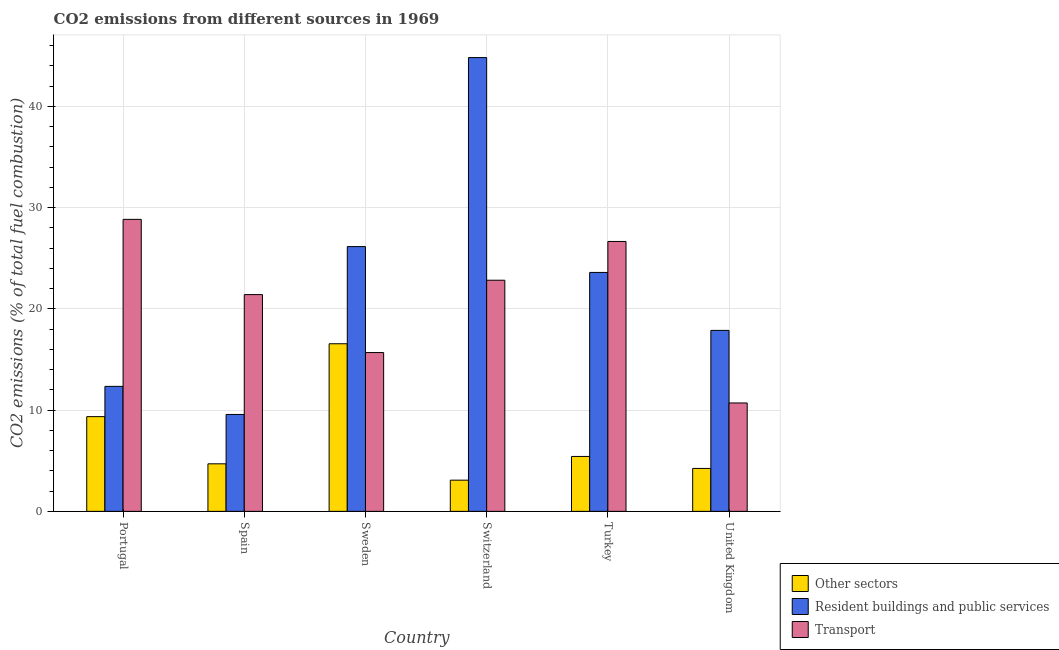How many different coloured bars are there?
Offer a very short reply. 3. How many groups of bars are there?
Provide a succinct answer. 6. How many bars are there on the 4th tick from the left?
Offer a terse response. 3. How many bars are there on the 4th tick from the right?
Your response must be concise. 3. What is the percentage of co2 emissions from other sectors in Sweden?
Your answer should be very brief. 16.55. Across all countries, what is the maximum percentage of co2 emissions from transport?
Your answer should be compact. 28.83. Across all countries, what is the minimum percentage of co2 emissions from resident buildings and public services?
Ensure brevity in your answer.  9.57. In which country was the percentage of co2 emissions from resident buildings and public services maximum?
Provide a succinct answer. Switzerland. What is the total percentage of co2 emissions from resident buildings and public services in the graph?
Make the answer very short. 134.33. What is the difference between the percentage of co2 emissions from transport in Sweden and that in Switzerland?
Offer a terse response. -7.14. What is the difference between the percentage of co2 emissions from transport in Sweden and the percentage of co2 emissions from resident buildings and public services in Spain?
Give a very brief answer. 6.11. What is the average percentage of co2 emissions from other sectors per country?
Give a very brief answer. 7.22. What is the difference between the percentage of co2 emissions from other sectors and percentage of co2 emissions from transport in Spain?
Provide a succinct answer. -16.71. What is the ratio of the percentage of co2 emissions from resident buildings and public services in Sweden to that in Turkey?
Your answer should be compact. 1.11. Is the percentage of co2 emissions from other sectors in Spain less than that in United Kingdom?
Offer a terse response. No. What is the difference between the highest and the second highest percentage of co2 emissions from resident buildings and public services?
Make the answer very short. 18.66. What is the difference between the highest and the lowest percentage of co2 emissions from transport?
Your answer should be compact. 18.13. In how many countries, is the percentage of co2 emissions from resident buildings and public services greater than the average percentage of co2 emissions from resident buildings and public services taken over all countries?
Your answer should be compact. 3. What does the 3rd bar from the left in Portugal represents?
Your answer should be very brief. Transport. What does the 2nd bar from the right in Switzerland represents?
Offer a terse response. Resident buildings and public services. How many countries are there in the graph?
Offer a terse response. 6. What is the difference between two consecutive major ticks on the Y-axis?
Your response must be concise. 10. Does the graph contain any zero values?
Your response must be concise. No. Does the graph contain grids?
Make the answer very short. Yes. Where does the legend appear in the graph?
Ensure brevity in your answer.  Bottom right. How many legend labels are there?
Your response must be concise. 3. What is the title of the graph?
Give a very brief answer. CO2 emissions from different sources in 1969. Does "Ages 50+" appear as one of the legend labels in the graph?
Provide a short and direct response. No. What is the label or title of the X-axis?
Your answer should be very brief. Country. What is the label or title of the Y-axis?
Your answer should be compact. CO2 emissions (% of total fuel combustion). What is the CO2 emissions (% of total fuel combustion) in Other sectors in Portugal?
Your answer should be very brief. 9.35. What is the CO2 emissions (% of total fuel combustion) in Resident buildings and public services in Portugal?
Ensure brevity in your answer.  12.34. What is the CO2 emissions (% of total fuel combustion) of Transport in Portugal?
Offer a very short reply. 28.83. What is the CO2 emissions (% of total fuel combustion) in Other sectors in Spain?
Ensure brevity in your answer.  4.69. What is the CO2 emissions (% of total fuel combustion) of Resident buildings and public services in Spain?
Your response must be concise. 9.57. What is the CO2 emissions (% of total fuel combustion) in Transport in Spain?
Make the answer very short. 21.4. What is the CO2 emissions (% of total fuel combustion) in Other sectors in Sweden?
Keep it short and to the point. 16.55. What is the CO2 emissions (% of total fuel combustion) of Resident buildings and public services in Sweden?
Your answer should be compact. 26.15. What is the CO2 emissions (% of total fuel combustion) of Transport in Sweden?
Ensure brevity in your answer.  15.68. What is the CO2 emissions (% of total fuel combustion) of Other sectors in Switzerland?
Offer a very short reply. 3.08. What is the CO2 emissions (% of total fuel combustion) in Resident buildings and public services in Switzerland?
Your response must be concise. 44.81. What is the CO2 emissions (% of total fuel combustion) of Transport in Switzerland?
Offer a terse response. 22.82. What is the CO2 emissions (% of total fuel combustion) of Other sectors in Turkey?
Provide a short and direct response. 5.42. What is the CO2 emissions (% of total fuel combustion) in Resident buildings and public services in Turkey?
Provide a short and direct response. 23.59. What is the CO2 emissions (% of total fuel combustion) in Transport in Turkey?
Your answer should be very brief. 26.65. What is the CO2 emissions (% of total fuel combustion) in Other sectors in United Kingdom?
Ensure brevity in your answer.  4.24. What is the CO2 emissions (% of total fuel combustion) in Resident buildings and public services in United Kingdom?
Keep it short and to the point. 17.87. What is the CO2 emissions (% of total fuel combustion) in Transport in United Kingdom?
Offer a terse response. 10.7. Across all countries, what is the maximum CO2 emissions (% of total fuel combustion) in Other sectors?
Ensure brevity in your answer.  16.55. Across all countries, what is the maximum CO2 emissions (% of total fuel combustion) in Resident buildings and public services?
Your answer should be compact. 44.81. Across all countries, what is the maximum CO2 emissions (% of total fuel combustion) in Transport?
Your response must be concise. 28.83. Across all countries, what is the minimum CO2 emissions (% of total fuel combustion) of Other sectors?
Ensure brevity in your answer.  3.08. Across all countries, what is the minimum CO2 emissions (% of total fuel combustion) in Resident buildings and public services?
Keep it short and to the point. 9.57. Across all countries, what is the minimum CO2 emissions (% of total fuel combustion) in Transport?
Ensure brevity in your answer.  10.7. What is the total CO2 emissions (% of total fuel combustion) in Other sectors in the graph?
Your response must be concise. 43.34. What is the total CO2 emissions (% of total fuel combustion) in Resident buildings and public services in the graph?
Your answer should be very brief. 134.33. What is the total CO2 emissions (% of total fuel combustion) in Transport in the graph?
Offer a terse response. 126.1. What is the difference between the CO2 emissions (% of total fuel combustion) of Other sectors in Portugal and that in Spain?
Offer a very short reply. 4.66. What is the difference between the CO2 emissions (% of total fuel combustion) in Resident buildings and public services in Portugal and that in Spain?
Make the answer very short. 2.78. What is the difference between the CO2 emissions (% of total fuel combustion) of Transport in Portugal and that in Spain?
Provide a succinct answer. 7.43. What is the difference between the CO2 emissions (% of total fuel combustion) in Other sectors in Portugal and that in Sweden?
Give a very brief answer. -7.2. What is the difference between the CO2 emissions (% of total fuel combustion) of Resident buildings and public services in Portugal and that in Sweden?
Your answer should be very brief. -13.8. What is the difference between the CO2 emissions (% of total fuel combustion) of Transport in Portugal and that in Sweden?
Keep it short and to the point. 13.15. What is the difference between the CO2 emissions (% of total fuel combustion) in Other sectors in Portugal and that in Switzerland?
Your answer should be very brief. 6.27. What is the difference between the CO2 emissions (% of total fuel combustion) in Resident buildings and public services in Portugal and that in Switzerland?
Your answer should be compact. -32.47. What is the difference between the CO2 emissions (% of total fuel combustion) in Transport in Portugal and that in Switzerland?
Provide a short and direct response. 6.01. What is the difference between the CO2 emissions (% of total fuel combustion) in Other sectors in Portugal and that in Turkey?
Your response must be concise. 3.93. What is the difference between the CO2 emissions (% of total fuel combustion) of Resident buildings and public services in Portugal and that in Turkey?
Your response must be concise. -11.25. What is the difference between the CO2 emissions (% of total fuel combustion) in Transport in Portugal and that in Turkey?
Your answer should be very brief. 2.18. What is the difference between the CO2 emissions (% of total fuel combustion) in Other sectors in Portugal and that in United Kingdom?
Your answer should be compact. 5.11. What is the difference between the CO2 emissions (% of total fuel combustion) of Resident buildings and public services in Portugal and that in United Kingdom?
Give a very brief answer. -5.53. What is the difference between the CO2 emissions (% of total fuel combustion) in Transport in Portugal and that in United Kingdom?
Ensure brevity in your answer.  18.13. What is the difference between the CO2 emissions (% of total fuel combustion) in Other sectors in Spain and that in Sweden?
Provide a short and direct response. -11.85. What is the difference between the CO2 emissions (% of total fuel combustion) of Resident buildings and public services in Spain and that in Sweden?
Keep it short and to the point. -16.58. What is the difference between the CO2 emissions (% of total fuel combustion) of Transport in Spain and that in Sweden?
Make the answer very short. 5.72. What is the difference between the CO2 emissions (% of total fuel combustion) in Other sectors in Spain and that in Switzerland?
Offer a terse response. 1.61. What is the difference between the CO2 emissions (% of total fuel combustion) in Resident buildings and public services in Spain and that in Switzerland?
Ensure brevity in your answer.  -35.24. What is the difference between the CO2 emissions (% of total fuel combustion) in Transport in Spain and that in Switzerland?
Make the answer very short. -1.42. What is the difference between the CO2 emissions (% of total fuel combustion) in Other sectors in Spain and that in Turkey?
Give a very brief answer. -0.73. What is the difference between the CO2 emissions (% of total fuel combustion) in Resident buildings and public services in Spain and that in Turkey?
Keep it short and to the point. -14.03. What is the difference between the CO2 emissions (% of total fuel combustion) of Transport in Spain and that in Turkey?
Your response must be concise. -5.25. What is the difference between the CO2 emissions (% of total fuel combustion) of Other sectors in Spain and that in United Kingdom?
Make the answer very short. 0.46. What is the difference between the CO2 emissions (% of total fuel combustion) in Resident buildings and public services in Spain and that in United Kingdom?
Provide a succinct answer. -8.3. What is the difference between the CO2 emissions (% of total fuel combustion) of Transport in Spain and that in United Kingdom?
Provide a short and direct response. 10.7. What is the difference between the CO2 emissions (% of total fuel combustion) of Other sectors in Sweden and that in Switzerland?
Make the answer very short. 13.47. What is the difference between the CO2 emissions (% of total fuel combustion) of Resident buildings and public services in Sweden and that in Switzerland?
Provide a short and direct response. -18.66. What is the difference between the CO2 emissions (% of total fuel combustion) in Transport in Sweden and that in Switzerland?
Provide a succinct answer. -7.14. What is the difference between the CO2 emissions (% of total fuel combustion) of Other sectors in Sweden and that in Turkey?
Keep it short and to the point. 11.13. What is the difference between the CO2 emissions (% of total fuel combustion) in Resident buildings and public services in Sweden and that in Turkey?
Keep it short and to the point. 2.55. What is the difference between the CO2 emissions (% of total fuel combustion) of Transport in Sweden and that in Turkey?
Ensure brevity in your answer.  -10.97. What is the difference between the CO2 emissions (% of total fuel combustion) in Other sectors in Sweden and that in United Kingdom?
Provide a short and direct response. 12.31. What is the difference between the CO2 emissions (% of total fuel combustion) of Resident buildings and public services in Sweden and that in United Kingdom?
Provide a succinct answer. 8.28. What is the difference between the CO2 emissions (% of total fuel combustion) of Transport in Sweden and that in United Kingdom?
Make the answer very short. 4.98. What is the difference between the CO2 emissions (% of total fuel combustion) in Other sectors in Switzerland and that in Turkey?
Your answer should be compact. -2.34. What is the difference between the CO2 emissions (% of total fuel combustion) of Resident buildings and public services in Switzerland and that in Turkey?
Offer a very short reply. 21.22. What is the difference between the CO2 emissions (% of total fuel combustion) of Transport in Switzerland and that in Turkey?
Offer a very short reply. -3.83. What is the difference between the CO2 emissions (% of total fuel combustion) of Other sectors in Switzerland and that in United Kingdom?
Ensure brevity in your answer.  -1.16. What is the difference between the CO2 emissions (% of total fuel combustion) of Resident buildings and public services in Switzerland and that in United Kingdom?
Provide a succinct answer. 26.94. What is the difference between the CO2 emissions (% of total fuel combustion) of Transport in Switzerland and that in United Kingdom?
Your response must be concise. 12.12. What is the difference between the CO2 emissions (% of total fuel combustion) of Other sectors in Turkey and that in United Kingdom?
Ensure brevity in your answer.  1.18. What is the difference between the CO2 emissions (% of total fuel combustion) in Resident buildings and public services in Turkey and that in United Kingdom?
Provide a succinct answer. 5.72. What is the difference between the CO2 emissions (% of total fuel combustion) in Transport in Turkey and that in United Kingdom?
Keep it short and to the point. 15.95. What is the difference between the CO2 emissions (% of total fuel combustion) in Other sectors in Portugal and the CO2 emissions (% of total fuel combustion) in Resident buildings and public services in Spain?
Offer a very short reply. -0.21. What is the difference between the CO2 emissions (% of total fuel combustion) in Other sectors in Portugal and the CO2 emissions (% of total fuel combustion) in Transport in Spain?
Your response must be concise. -12.05. What is the difference between the CO2 emissions (% of total fuel combustion) of Resident buildings and public services in Portugal and the CO2 emissions (% of total fuel combustion) of Transport in Spain?
Provide a succinct answer. -9.06. What is the difference between the CO2 emissions (% of total fuel combustion) of Other sectors in Portugal and the CO2 emissions (% of total fuel combustion) of Resident buildings and public services in Sweden?
Ensure brevity in your answer.  -16.79. What is the difference between the CO2 emissions (% of total fuel combustion) of Other sectors in Portugal and the CO2 emissions (% of total fuel combustion) of Transport in Sweden?
Give a very brief answer. -6.33. What is the difference between the CO2 emissions (% of total fuel combustion) of Resident buildings and public services in Portugal and the CO2 emissions (% of total fuel combustion) of Transport in Sweden?
Make the answer very short. -3.34. What is the difference between the CO2 emissions (% of total fuel combustion) in Other sectors in Portugal and the CO2 emissions (% of total fuel combustion) in Resident buildings and public services in Switzerland?
Provide a succinct answer. -35.46. What is the difference between the CO2 emissions (% of total fuel combustion) in Other sectors in Portugal and the CO2 emissions (% of total fuel combustion) in Transport in Switzerland?
Your answer should be very brief. -13.47. What is the difference between the CO2 emissions (% of total fuel combustion) in Resident buildings and public services in Portugal and the CO2 emissions (% of total fuel combustion) in Transport in Switzerland?
Your response must be concise. -10.48. What is the difference between the CO2 emissions (% of total fuel combustion) in Other sectors in Portugal and the CO2 emissions (% of total fuel combustion) in Resident buildings and public services in Turkey?
Keep it short and to the point. -14.24. What is the difference between the CO2 emissions (% of total fuel combustion) in Other sectors in Portugal and the CO2 emissions (% of total fuel combustion) in Transport in Turkey?
Ensure brevity in your answer.  -17.3. What is the difference between the CO2 emissions (% of total fuel combustion) in Resident buildings and public services in Portugal and the CO2 emissions (% of total fuel combustion) in Transport in Turkey?
Your answer should be very brief. -14.31. What is the difference between the CO2 emissions (% of total fuel combustion) of Other sectors in Portugal and the CO2 emissions (% of total fuel combustion) of Resident buildings and public services in United Kingdom?
Provide a succinct answer. -8.52. What is the difference between the CO2 emissions (% of total fuel combustion) in Other sectors in Portugal and the CO2 emissions (% of total fuel combustion) in Transport in United Kingdom?
Your answer should be compact. -1.35. What is the difference between the CO2 emissions (% of total fuel combustion) of Resident buildings and public services in Portugal and the CO2 emissions (% of total fuel combustion) of Transport in United Kingdom?
Provide a short and direct response. 1.64. What is the difference between the CO2 emissions (% of total fuel combustion) of Other sectors in Spain and the CO2 emissions (% of total fuel combustion) of Resident buildings and public services in Sweden?
Keep it short and to the point. -21.45. What is the difference between the CO2 emissions (% of total fuel combustion) in Other sectors in Spain and the CO2 emissions (% of total fuel combustion) in Transport in Sweden?
Your answer should be very brief. -10.99. What is the difference between the CO2 emissions (% of total fuel combustion) of Resident buildings and public services in Spain and the CO2 emissions (% of total fuel combustion) of Transport in Sweden?
Offer a terse response. -6.11. What is the difference between the CO2 emissions (% of total fuel combustion) in Other sectors in Spain and the CO2 emissions (% of total fuel combustion) in Resident buildings and public services in Switzerland?
Offer a very short reply. -40.12. What is the difference between the CO2 emissions (% of total fuel combustion) in Other sectors in Spain and the CO2 emissions (% of total fuel combustion) in Transport in Switzerland?
Your answer should be very brief. -18.13. What is the difference between the CO2 emissions (% of total fuel combustion) of Resident buildings and public services in Spain and the CO2 emissions (% of total fuel combustion) of Transport in Switzerland?
Make the answer very short. -13.26. What is the difference between the CO2 emissions (% of total fuel combustion) of Other sectors in Spain and the CO2 emissions (% of total fuel combustion) of Resident buildings and public services in Turkey?
Ensure brevity in your answer.  -18.9. What is the difference between the CO2 emissions (% of total fuel combustion) of Other sectors in Spain and the CO2 emissions (% of total fuel combustion) of Transport in Turkey?
Your answer should be very brief. -21.96. What is the difference between the CO2 emissions (% of total fuel combustion) in Resident buildings and public services in Spain and the CO2 emissions (% of total fuel combustion) in Transport in Turkey?
Ensure brevity in your answer.  -17.08. What is the difference between the CO2 emissions (% of total fuel combustion) of Other sectors in Spain and the CO2 emissions (% of total fuel combustion) of Resident buildings and public services in United Kingdom?
Your answer should be compact. -13.17. What is the difference between the CO2 emissions (% of total fuel combustion) of Other sectors in Spain and the CO2 emissions (% of total fuel combustion) of Transport in United Kingdom?
Provide a succinct answer. -6.01. What is the difference between the CO2 emissions (% of total fuel combustion) in Resident buildings and public services in Spain and the CO2 emissions (% of total fuel combustion) in Transport in United Kingdom?
Your response must be concise. -1.14. What is the difference between the CO2 emissions (% of total fuel combustion) of Other sectors in Sweden and the CO2 emissions (% of total fuel combustion) of Resident buildings and public services in Switzerland?
Provide a short and direct response. -28.26. What is the difference between the CO2 emissions (% of total fuel combustion) of Other sectors in Sweden and the CO2 emissions (% of total fuel combustion) of Transport in Switzerland?
Your answer should be compact. -6.27. What is the difference between the CO2 emissions (% of total fuel combustion) in Resident buildings and public services in Sweden and the CO2 emissions (% of total fuel combustion) in Transport in Switzerland?
Offer a terse response. 3.32. What is the difference between the CO2 emissions (% of total fuel combustion) in Other sectors in Sweden and the CO2 emissions (% of total fuel combustion) in Resident buildings and public services in Turkey?
Keep it short and to the point. -7.04. What is the difference between the CO2 emissions (% of total fuel combustion) in Other sectors in Sweden and the CO2 emissions (% of total fuel combustion) in Transport in Turkey?
Your answer should be very brief. -10.1. What is the difference between the CO2 emissions (% of total fuel combustion) in Resident buildings and public services in Sweden and the CO2 emissions (% of total fuel combustion) in Transport in Turkey?
Offer a very short reply. -0.51. What is the difference between the CO2 emissions (% of total fuel combustion) of Other sectors in Sweden and the CO2 emissions (% of total fuel combustion) of Resident buildings and public services in United Kingdom?
Keep it short and to the point. -1.32. What is the difference between the CO2 emissions (% of total fuel combustion) of Other sectors in Sweden and the CO2 emissions (% of total fuel combustion) of Transport in United Kingdom?
Make the answer very short. 5.85. What is the difference between the CO2 emissions (% of total fuel combustion) in Resident buildings and public services in Sweden and the CO2 emissions (% of total fuel combustion) in Transport in United Kingdom?
Offer a very short reply. 15.44. What is the difference between the CO2 emissions (% of total fuel combustion) of Other sectors in Switzerland and the CO2 emissions (% of total fuel combustion) of Resident buildings and public services in Turkey?
Give a very brief answer. -20.51. What is the difference between the CO2 emissions (% of total fuel combustion) of Other sectors in Switzerland and the CO2 emissions (% of total fuel combustion) of Transport in Turkey?
Keep it short and to the point. -23.57. What is the difference between the CO2 emissions (% of total fuel combustion) in Resident buildings and public services in Switzerland and the CO2 emissions (% of total fuel combustion) in Transport in Turkey?
Keep it short and to the point. 18.16. What is the difference between the CO2 emissions (% of total fuel combustion) in Other sectors in Switzerland and the CO2 emissions (% of total fuel combustion) in Resident buildings and public services in United Kingdom?
Give a very brief answer. -14.79. What is the difference between the CO2 emissions (% of total fuel combustion) in Other sectors in Switzerland and the CO2 emissions (% of total fuel combustion) in Transport in United Kingdom?
Provide a short and direct response. -7.62. What is the difference between the CO2 emissions (% of total fuel combustion) in Resident buildings and public services in Switzerland and the CO2 emissions (% of total fuel combustion) in Transport in United Kingdom?
Offer a very short reply. 34.11. What is the difference between the CO2 emissions (% of total fuel combustion) of Other sectors in Turkey and the CO2 emissions (% of total fuel combustion) of Resident buildings and public services in United Kingdom?
Offer a very short reply. -12.45. What is the difference between the CO2 emissions (% of total fuel combustion) of Other sectors in Turkey and the CO2 emissions (% of total fuel combustion) of Transport in United Kingdom?
Give a very brief answer. -5.28. What is the difference between the CO2 emissions (% of total fuel combustion) of Resident buildings and public services in Turkey and the CO2 emissions (% of total fuel combustion) of Transport in United Kingdom?
Keep it short and to the point. 12.89. What is the average CO2 emissions (% of total fuel combustion) in Other sectors per country?
Your answer should be compact. 7.22. What is the average CO2 emissions (% of total fuel combustion) in Resident buildings and public services per country?
Provide a short and direct response. 22.39. What is the average CO2 emissions (% of total fuel combustion) in Transport per country?
Offer a very short reply. 21.02. What is the difference between the CO2 emissions (% of total fuel combustion) of Other sectors and CO2 emissions (% of total fuel combustion) of Resident buildings and public services in Portugal?
Your answer should be very brief. -2.99. What is the difference between the CO2 emissions (% of total fuel combustion) of Other sectors and CO2 emissions (% of total fuel combustion) of Transport in Portugal?
Provide a short and direct response. -19.48. What is the difference between the CO2 emissions (% of total fuel combustion) in Resident buildings and public services and CO2 emissions (% of total fuel combustion) in Transport in Portugal?
Offer a very short reply. -16.49. What is the difference between the CO2 emissions (% of total fuel combustion) of Other sectors and CO2 emissions (% of total fuel combustion) of Resident buildings and public services in Spain?
Provide a short and direct response. -4.87. What is the difference between the CO2 emissions (% of total fuel combustion) in Other sectors and CO2 emissions (% of total fuel combustion) in Transport in Spain?
Make the answer very short. -16.71. What is the difference between the CO2 emissions (% of total fuel combustion) in Resident buildings and public services and CO2 emissions (% of total fuel combustion) in Transport in Spain?
Your answer should be compact. -11.84. What is the difference between the CO2 emissions (% of total fuel combustion) in Other sectors and CO2 emissions (% of total fuel combustion) in Resident buildings and public services in Sweden?
Keep it short and to the point. -9.6. What is the difference between the CO2 emissions (% of total fuel combustion) of Other sectors and CO2 emissions (% of total fuel combustion) of Transport in Sweden?
Provide a short and direct response. 0.87. What is the difference between the CO2 emissions (% of total fuel combustion) in Resident buildings and public services and CO2 emissions (% of total fuel combustion) in Transport in Sweden?
Provide a short and direct response. 10.46. What is the difference between the CO2 emissions (% of total fuel combustion) of Other sectors and CO2 emissions (% of total fuel combustion) of Resident buildings and public services in Switzerland?
Your answer should be compact. -41.73. What is the difference between the CO2 emissions (% of total fuel combustion) in Other sectors and CO2 emissions (% of total fuel combustion) in Transport in Switzerland?
Give a very brief answer. -19.74. What is the difference between the CO2 emissions (% of total fuel combustion) in Resident buildings and public services and CO2 emissions (% of total fuel combustion) in Transport in Switzerland?
Give a very brief answer. 21.99. What is the difference between the CO2 emissions (% of total fuel combustion) in Other sectors and CO2 emissions (% of total fuel combustion) in Resident buildings and public services in Turkey?
Make the answer very short. -18.17. What is the difference between the CO2 emissions (% of total fuel combustion) in Other sectors and CO2 emissions (% of total fuel combustion) in Transport in Turkey?
Your response must be concise. -21.23. What is the difference between the CO2 emissions (% of total fuel combustion) in Resident buildings and public services and CO2 emissions (% of total fuel combustion) in Transport in Turkey?
Ensure brevity in your answer.  -3.06. What is the difference between the CO2 emissions (% of total fuel combustion) in Other sectors and CO2 emissions (% of total fuel combustion) in Resident buildings and public services in United Kingdom?
Offer a very short reply. -13.63. What is the difference between the CO2 emissions (% of total fuel combustion) of Other sectors and CO2 emissions (% of total fuel combustion) of Transport in United Kingdom?
Your answer should be very brief. -6.46. What is the difference between the CO2 emissions (% of total fuel combustion) in Resident buildings and public services and CO2 emissions (% of total fuel combustion) in Transport in United Kingdom?
Offer a terse response. 7.17. What is the ratio of the CO2 emissions (% of total fuel combustion) in Other sectors in Portugal to that in Spain?
Offer a very short reply. 1.99. What is the ratio of the CO2 emissions (% of total fuel combustion) of Resident buildings and public services in Portugal to that in Spain?
Give a very brief answer. 1.29. What is the ratio of the CO2 emissions (% of total fuel combustion) in Transport in Portugal to that in Spain?
Make the answer very short. 1.35. What is the ratio of the CO2 emissions (% of total fuel combustion) in Other sectors in Portugal to that in Sweden?
Offer a terse response. 0.57. What is the ratio of the CO2 emissions (% of total fuel combustion) of Resident buildings and public services in Portugal to that in Sweden?
Offer a terse response. 0.47. What is the ratio of the CO2 emissions (% of total fuel combustion) of Transport in Portugal to that in Sweden?
Your answer should be very brief. 1.84. What is the ratio of the CO2 emissions (% of total fuel combustion) in Other sectors in Portugal to that in Switzerland?
Ensure brevity in your answer.  3.04. What is the ratio of the CO2 emissions (% of total fuel combustion) in Resident buildings and public services in Portugal to that in Switzerland?
Your answer should be very brief. 0.28. What is the ratio of the CO2 emissions (% of total fuel combustion) of Transport in Portugal to that in Switzerland?
Your response must be concise. 1.26. What is the ratio of the CO2 emissions (% of total fuel combustion) of Other sectors in Portugal to that in Turkey?
Your answer should be very brief. 1.73. What is the ratio of the CO2 emissions (% of total fuel combustion) in Resident buildings and public services in Portugal to that in Turkey?
Ensure brevity in your answer.  0.52. What is the ratio of the CO2 emissions (% of total fuel combustion) of Transport in Portugal to that in Turkey?
Your answer should be compact. 1.08. What is the ratio of the CO2 emissions (% of total fuel combustion) in Other sectors in Portugal to that in United Kingdom?
Offer a very short reply. 2.21. What is the ratio of the CO2 emissions (% of total fuel combustion) of Resident buildings and public services in Portugal to that in United Kingdom?
Ensure brevity in your answer.  0.69. What is the ratio of the CO2 emissions (% of total fuel combustion) of Transport in Portugal to that in United Kingdom?
Your response must be concise. 2.69. What is the ratio of the CO2 emissions (% of total fuel combustion) in Other sectors in Spain to that in Sweden?
Give a very brief answer. 0.28. What is the ratio of the CO2 emissions (% of total fuel combustion) of Resident buildings and public services in Spain to that in Sweden?
Offer a terse response. 0.37. What is the ratio of the CO2 emissions (% of total fuel combustion) in Transport in Spain to that in Sweden?
Provide a succinct answer. 1.36. What is the ratio of the CO2 emissions (% of total fuel combustion) of Other sectors in Spain to that in Switzerland?
Ensure brevity in your answer.  1.52. What is the ratio of the CO2 emissions (% of total fuel combustion) in Resident buildings and public services in Spain to that in Switzerland?
Offer a terse response. 0.21. What is the ratio of the CO2 emissions (% of total fuel combustion) of Transport in Spain to that in Switzerland?
Ensure brevity in your answer.  0.94. What is the ratio of the CO2 emissions (% of total fuel combustion) in Other sectors in Spain to that in Turkey?
Offer a very short reply. 0.87. What is the ratio of the CO2 emissions (% of total fuel combustion) in Resident buildings and public services in Spain to that in Turkey?
Offer a terse response. 0.41. What is the ratio of the CO2 emissions (% of total fuel combustion) of Transport in Spain to that in Turkey?
Your response must be concise. 0.8. What is the ratio of the CO2 emissions (% of total fuel combustion) of Other sectors in Spain to that in United Kingdom?
Make the answer very short. 1.11. What is the ratio of the CO2 emissions (% of total fuel combustion) of Resident buildings and public services in Spain to that in United Kingdom?
Keep it short and to the point. 0.54. What is the ratio of the CO2 emissions (% of total fuel combustion) in Transport in Spain to that in United Kingdom?
Offer a very short reply. 2. What is the ratio of the CO2 emissions (% of total fuel combustion) of Other sectors in Sweden to that in Switzerland?
Your answer should be very brief. 5.37. What is the ratio of the CO2 emissions (% of total fuel combustion) of Resident buildings and public services in Sweden to that in Switzerland?
Keep it short and to the point. 0.58. What is the ratio of the CO2 emissions (% of total fuel combustion) in Transport in Sweden to that in Switzerland?
Your answer should be compact. 0.69. What is the ratio of the CO2 emissions (% of total fuel combustion) of Other sectors in Sweden to that in Turkey?
Your response must be concise. 3.05. What is the ratio of the CO2 emissions (% of total fuel combustion) in Resident buildings and public services in Sweden to that in Turkey?
Make the answer very short. 1.11. What is the ratio of the CO2 emissions (% of total fuel combustion) in Transport in Sweden to that in Turkey?
Provide a short and direct response. 0.59. What is the ratio of the CO2 emissions (% of total fuel combustion) of Other sectors in Sweden to that in United Kingdom?
Provide a short and direct response. 3.9. What is the ratio of the CO2 emissions (% of total fuel combustion) in Resident buildings and public services in Sweden to that in United Kingdom?
Keep it short and to the point. 1.46. What is the ratio of the CO2 emissions (% of total fuel combustion) of Transport in Sweden to that in United Kingdom?
Offer a very short reply. 1.47. What is the ratio of the CO2 emissions (% of total fuel combustion) in Other sectors in Switzerland to that in Turkey?
Give a very brief answer. 0.57. What is the ratio of the CO2 emissions (% of total fuel combustion) of Resident buildings and public services in Switzerland to that in Turkey?
Keep it short and to the point. 1.9. What is the ratio of the CO2 emissions (% of total fuel combustion) of Transport in Switzerland to that in Turkey?
Give a very brief answer. 0.86. What is the ratio of the CO2 emissions (% of total fuel combustion) in Other sectors in Switzerland to that in United Kingdom?
Your answer should be very brief. 0.73. What is the ratio of the CO2 emissions (% of total fuel combustion) in Resident buildings and public services in Switzerland to that in United Kingdom?
Keep it short and to the point. 2.51. What is the ratio of the CO2 emissions (% of total fuel combustion) in Transport in Switzerland to that in United Kingdom?
Provide a succinct answer. 2.13. What is the ratio of the CO2 emissions (% of total fuel combustion) of Other sectors in Turkey to that in United Kingdom?
Give a very brief answer. 1.28. What is the ratio of the CO2 emissions (% of total fuel combustion) of Resident buildings and public services in Turkey to that in United Kingdom?
Provide a short and direct response. 1.32. What is the ratio of the CO2 emissions (% of total fuel combustion) in Transport in Turkey to that in United Kingdom?
Provide a succinct answer. 2.49. What is the difference between the highest and the second highest CO2 emissions (% of total fuel combustion) in Other sectors?
Keep it short and to the point. 7.2. What is the difference between the highest and the second highest CO2 emissions (% of total fuel combustion) of Resident buildings and public services?
Your answer should be compact. 18.66. What is the difference between the highest and the second highest CO2 emissions (% of total fuel combustion) of Transport?
Ensure brevity in your answer.  2.18. What is the difference between the highest and the lowest CO2 emissions (% of total fuel combustion) of Other sectors?
Ensure brevity in your answer.  13.47. What is the difference between the highest and the lowest CO2 emissions (% of total fuel combustion) of Resident buildings and public services?
Make the answer very short. 35.24. What is the difference between the highest and the lowest CO2 emissions (% of total fuel combustion) in Transport?
Give a very brief answer. 18.13. 